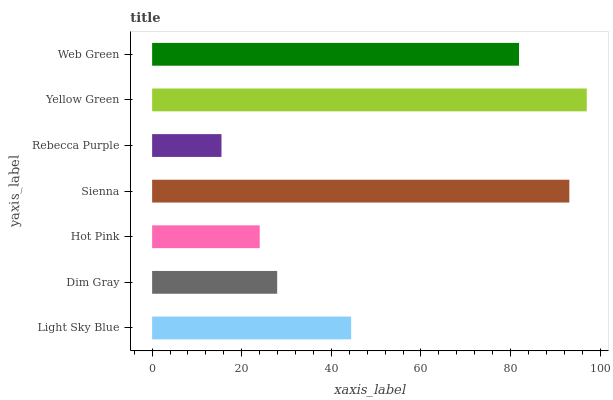Is Rebecca Purple the minimum?
Answer yes or no. Yes. Is Yellow Green the maximum?
Answer yes or no. Yes. Is Dim Gray the minimum?
Answer yes or no. No. Is Dim Gray the maximum?
Answer yes or no. No. Is Light Sky Blue greater than Dim Gray?
Answer yes or no. Yes. Is Dim Gray less than Light Sky Blue?
Answer yes or no. Yes. Is Dim Gray greater than Light Sky Blue?
Answer yes or no. No. Is Light Sky Blue less than Dim Gray?
Answer yes or no. No. Is Light Sky Blue the high median?
Answer yes or no. Yes. Is Light Sky Blue the low median?
Answer yes or no. Yes. Is Sienna the high median?
Answer yes or no. No. Is Yellow Green the low median?
Answer yes or no. No. 